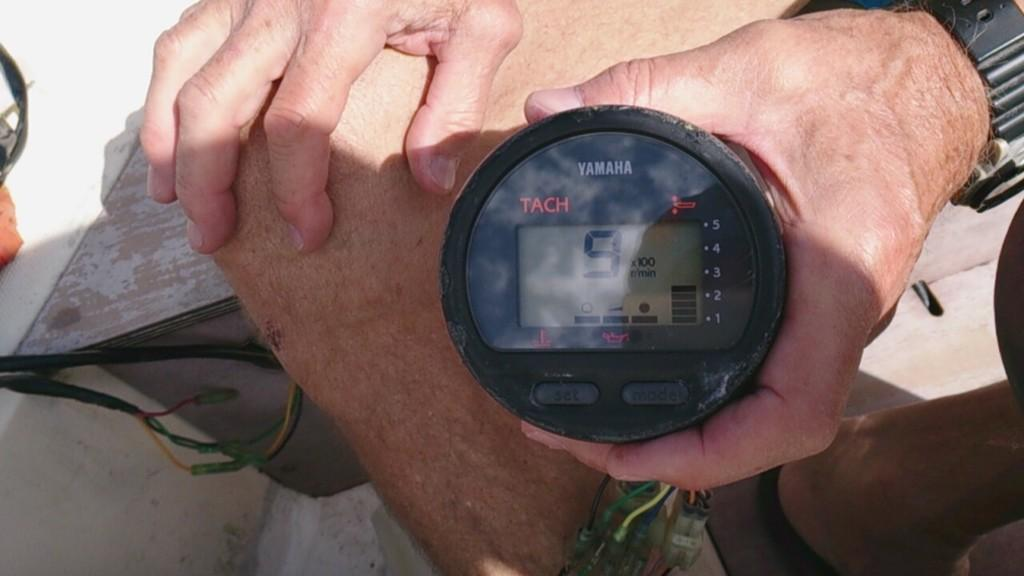<image>
Create a compact narrative representing the image presented. A tachometer made by Yamaha with the number 9 on the display. 